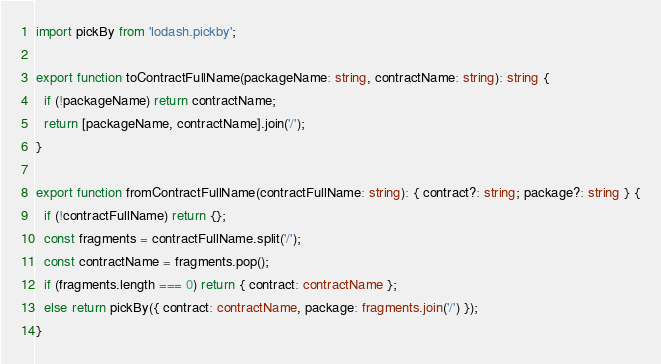<code> <loc_0><loc_0><loc_500><loc_500><_TypeScript_>import pickBy from 'lodash.pickby';

export function toContractFullName(packageName: string, contractName: string): string {
  if (!packageName) return contractName;
  return [packageName, contractName].join('/');
}

export function fromContractFullName(contractFullName: string): { contract?: string; package?: string } {
  if (!contractFullName) return {};
  const fragments = contractFullName.split('/');
  const contractName = fragments.pop();
  if (fragments.length === 0) return { contract: contractName };
  else return pickBy({ contract: contractName, package: fragments.join('/') });
}
</code> 